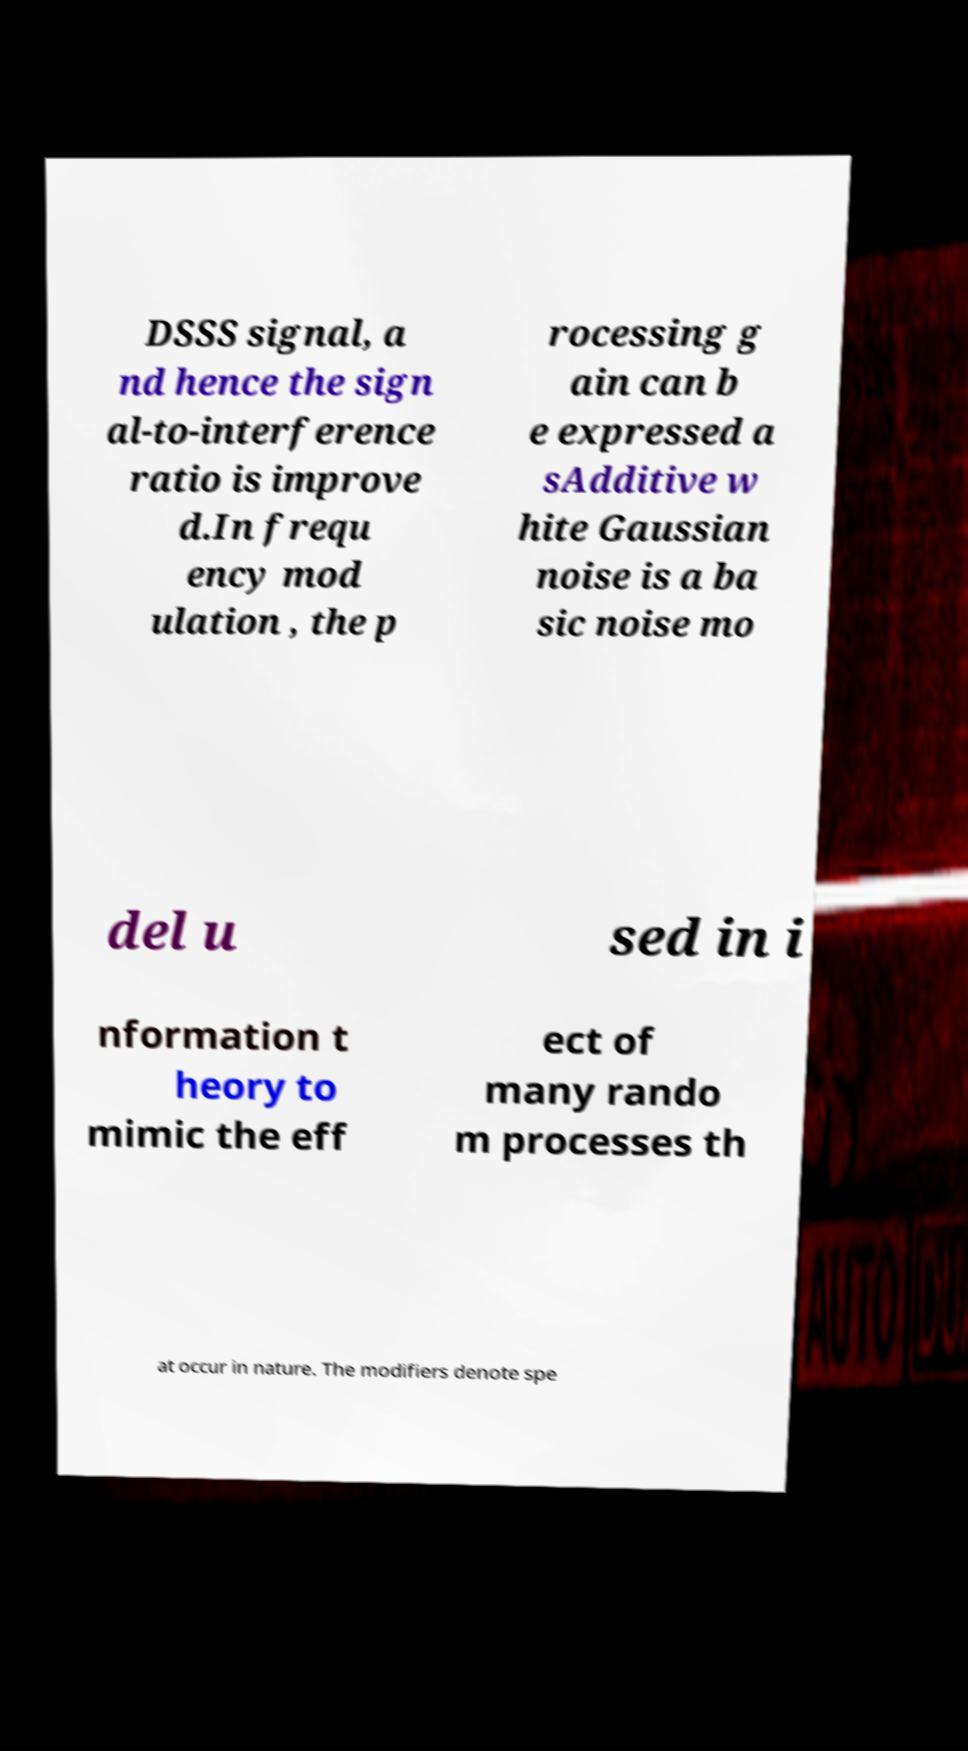I need the written content from this picture converted into text. Can you do that? DSSS signal, a nd hence the sign al-to-interference ratio is improve d.In frequ ency mod ulation , the p rocessing g ain can b e expressed a sAdditive w hite Gaussian noise is a ba sic noise mo del u sed in i nformation t heory to mimic the eff ect of many rando m processes th at occur in nature. The modifiers denote spe 